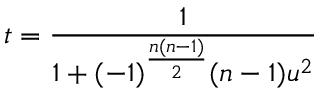<formula> <loc_0><loc_0><loc_500><loc_500>t = { \frac { 1 } { 1 + ( - 1 ) ^ { \frac { n ( n - 1 ) } { 2 } } ( n - 1 ) u ^ { 2 } } }</formula> 